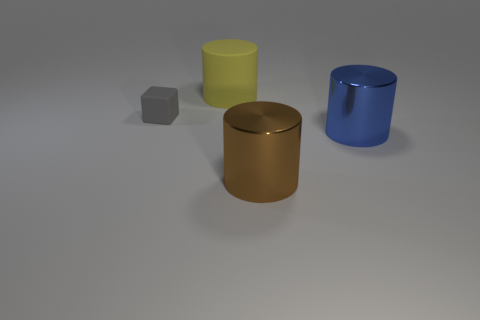Add 1 yellow cylinders. How many objects exist? 5 Subtract all cubes. How many objects are left? 3 Subtract all big brown objects. Subtract all tiny yellow blocks. How many objects are left? 3 Add 2 large blue cylinders. How many large blue cylinders are left? 3 Add 3 gray rubber cubes. How many gray rubber cubes exist? 4 Subtract 1 blue cylinders. How many objects are left? 3 